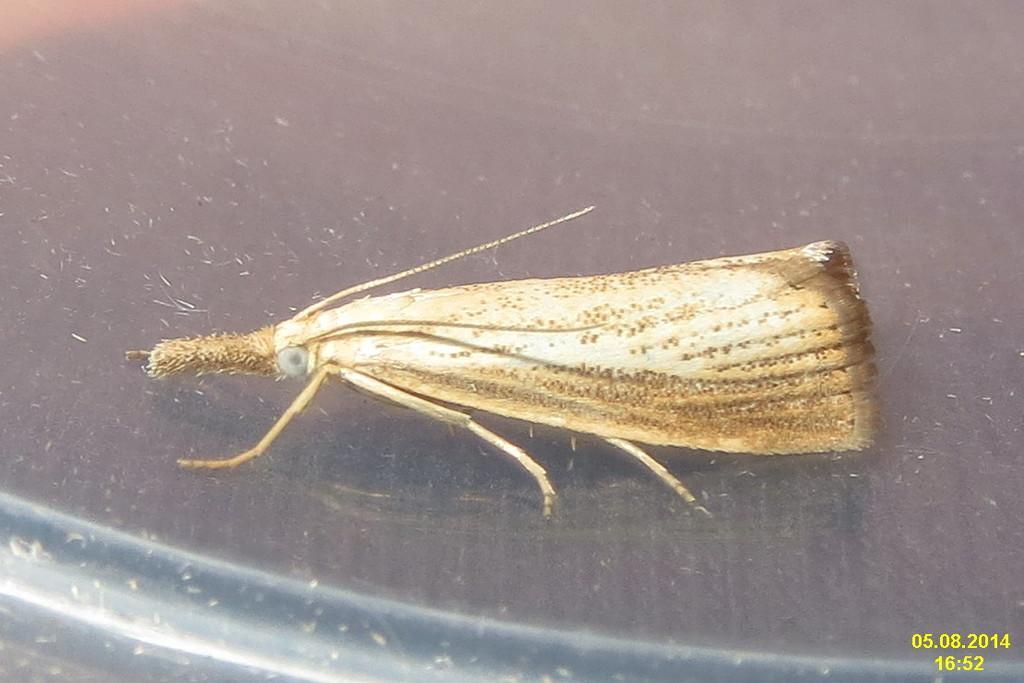How would you summarize this image in a sentence or two? In this picture we can see an insect on an object and on the image there is a watermark. 